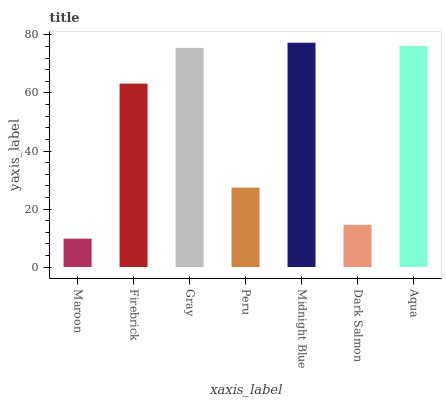Is Firebrick the minimum?
Answer yes or no. No. Is Firebrick the maximum?
Answer yes or no. No. Is Firebrick greater than Maroon?
Answer yes or no. Yes. Is Maroon less than Firebrick?
Answer yes or no. Yes. Is Maroon greater than Firebrick?
Answer yes or no. No. Is Firebrick less than Maroon?
Answer yes or no. No. Is Firebrick the high median?
Answer yes or no. Yes. Is Firebrick the low median?
Answer yes or no. Yes. Is Peru the high median?
Answer yes or no. No. Is Peru the low median?
Answer yes or no. No. 